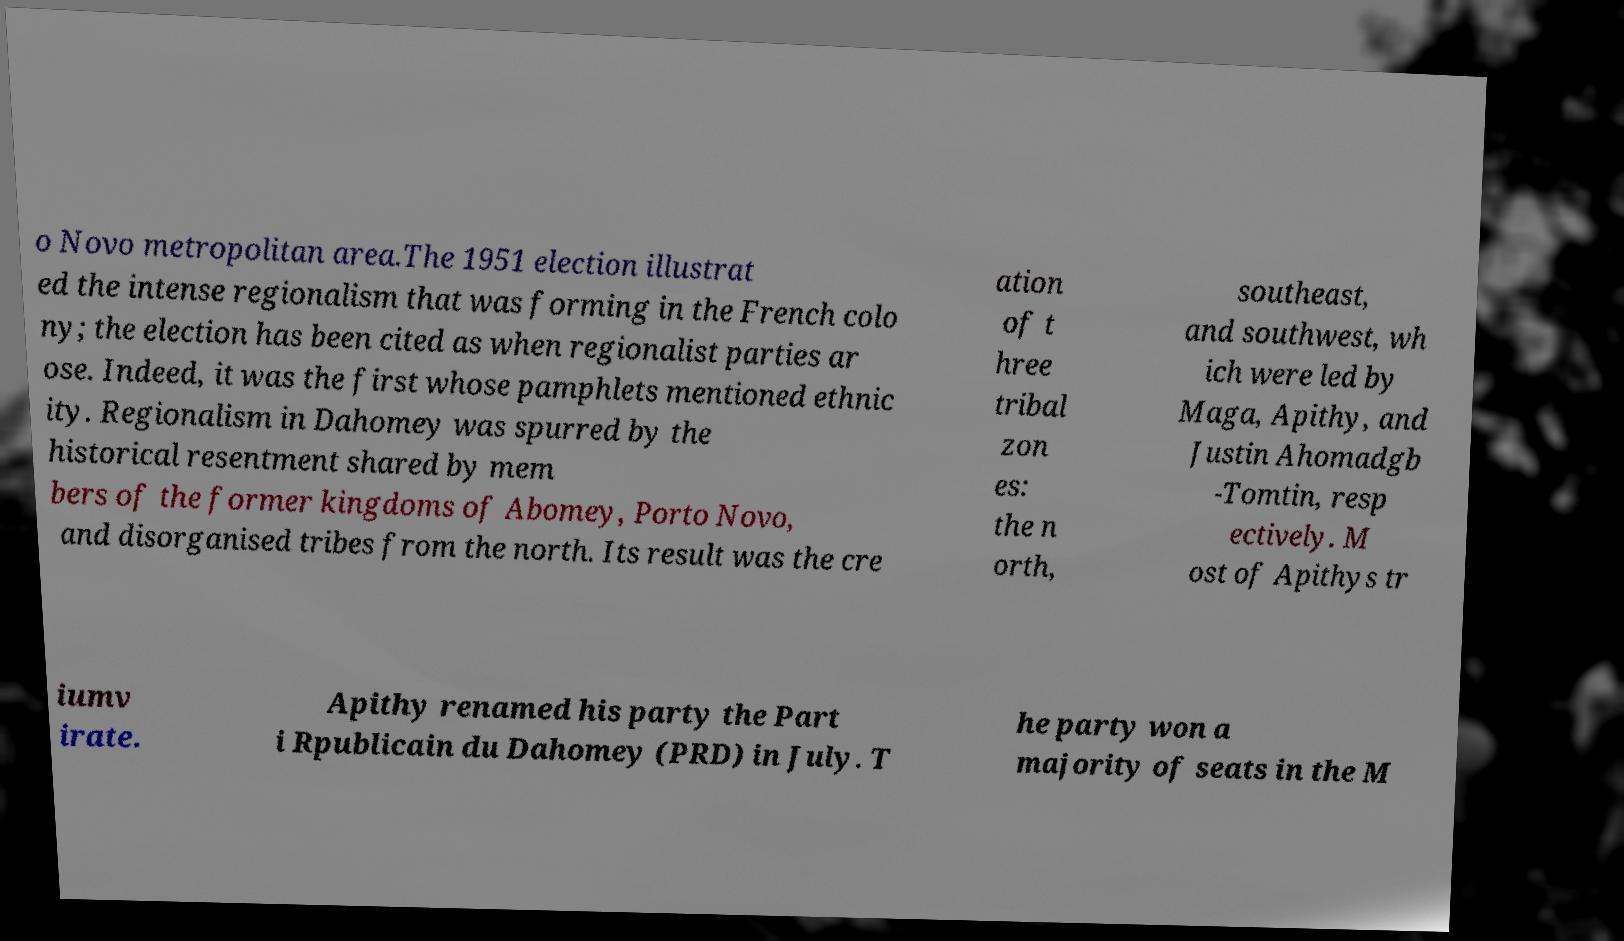What messages or text are displayed in this image? I need them in a readable, typed format. o Novo metropolitan area.The 1951 election illustrat ed the intense regionalism that was forming in the French colo ny; the election has been cited as when regionalist parties ar ose. Indeed, it was the first whose pamphlets mentioned ethnic ity. Regionalism in Dahomey was spurred by the historical resentment shared by mem bers of the former kingdoms of Abomey, Porto Novo, and disorganised tribes from the north. Its result was the cre ation of t hree tribal zon es: the n orth, southeast, and southwest, wh ich were led by Maga, Apithy, and Justin Ahomadgb -Tomtin, resp ectively. M ost of Apithys tr iumv irate. Apithy renamed his party the Part i Rpublicain du Dahomey (PRD) in July. T he party won a majority of seats in the M 